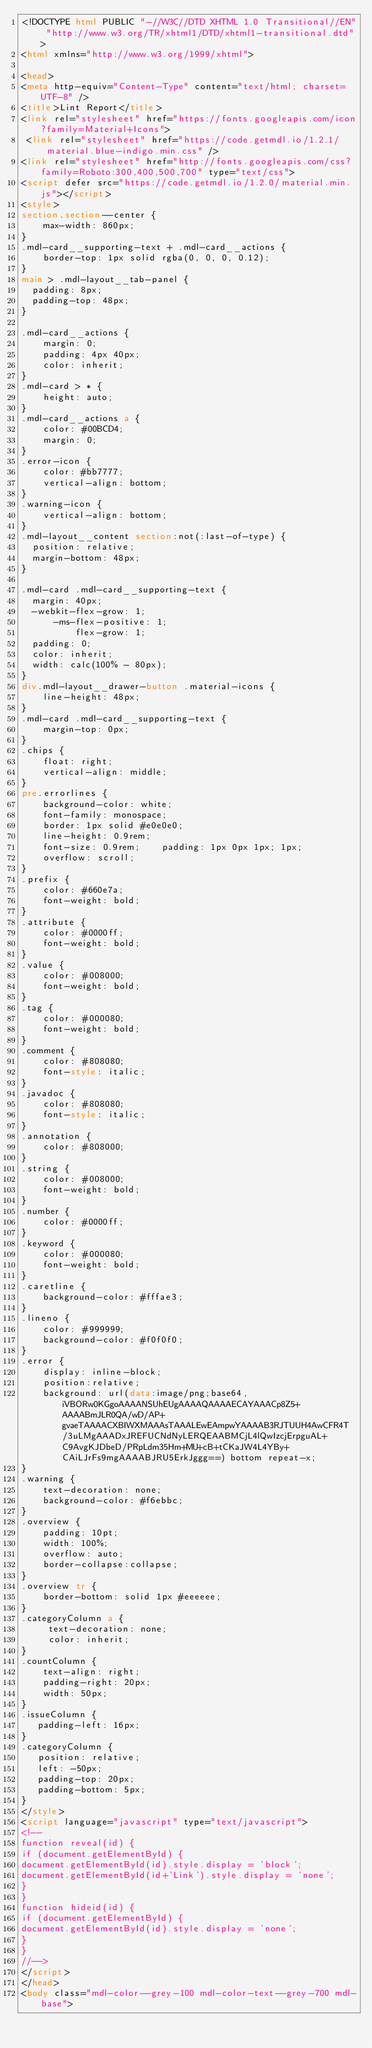Convert code to text. <code><loc_0><loc_0><loc_500><loc_500><_HTML_><!DOCTYPE html PUBLIC "-//W3C//DTD XHTML 1.0 Transitional//EN" "http://www.w3.org/TR/xhtml1/DTD/xhtml1-transitional.dtd">
<html xmlns="http://www.w3.org/1999/xhtml">

<head>
<meta http-equiv="Content-Type" content="text/html; charset=UTF-8" />
<title>Lint Report</title>
<link rel="stylesheet" href="https://fonts.googleapis.com/icon?family=Material+Icons">
 <link rel="stylesheet" href="https://code.getmdl.io/1.2.1/material.blue-indigo.min.css" />
<link rel="stylesheet" href="http://fonts.googleapis.com/css?family=Roboto:300,400,500,700" type="text/css">
<script defer src="https://code.getmdl.io/1.2.0/material.min.js"></script>
<style>
section.section--center {
    max-width: 860px;
}
.mdl-card__supporting-text + .mdl-card__actions {
    border-top: 1px solid rgba(0, 0, 0, 0.12);
}
main > .mdl-layout__tab-panel {
  padding: 8px;
  padding-top: 48px;
}

.mdl-card__actions {
    margin: 0;
    padding: 4px 40px;
    color: inherit;
}
.mdl-card > * {
    height: auto;
}
.mdl-card__actions a {
    color: #00BCD4;
    margin: 0;
}
.error-icon {
    color: #bb7777;
    vertical-align: bottom;
}
.warning-icon {
    vertical-align: bottom;
}
.mdl-layout__content section:not(:last-of-type) {
  position: relative;
  margin-bottom: 48px;
}

.mdl-card .mdl-card__supporting-text {
  margin: 40px;
  -webkit-flex-grow: 1;
      -ms-flex-positive: 1;
          flex-grow: 1;
  padding: 0;
  color: inherit;
  width: calc(100% - 80px);
}
div.mdl-layout__drawer-button .material-icons {
    line-height: 48px;
}
.mdl-card .mdl-card__supporting-text {
    margin-top: 0px;
}
.chips {
    float: right;
    vertical-align: middle;
}
pre.errorlines {
    background-color: white;
    font-family: monospace;
    border: 1px solid #e0e0e0;
    line-height: 0.9rem;
    font-size: 0.9rem;    padding: 1px 0px 1px; 1px;
    overflow: scroll;
}
.prefix {
    color: #660e7a;
    font-weight: bold;
}
.attribute {
    color: #0000ff;
    font-weight: bold;
}
.value {
    color: #008000;
    font-weight: bold;
}
.tag {
    color: #000080;
    font-weight: bold;
}
.comment {
    color: #808080;
    font-style: italic;
}
.javadoc {
    color: #808080;
    font-style: italic;
}
.annotation {
    color: #808000;
}
.string {
    color: #008000;
    font-weight: bold;
}
.number {
    color: #0000ff;
}
.keyword {
    color: #000080;
    font-weight: bold;
}
.caretline {
    background-color: #fffae3;
}
.lineno {
    color: #999999;
    background-color: #f0f0f0;
}
.error {
    display: inline-block;
    position:relative;
    background: url(data:image/png;base64,iVBORw0KGgoAAAANSUhEUgAAAAQAAAAECAYAAACp8Z5+AAAABmJLR0QA/wD/AP+gvaeTAAAACXBIWXMAAAsTAAALEwEAmpwYAAAAB3RJTUUH4AwCFR4T/3uLMgAAADxJREFUCNdNyLERQEAABMCjL4lQwIzcjErpguAL+C9AvgKJDbeD/PRpLdm35Hm+MU+cB+tCKaJW4L4YBy+CAiLJrFs9mgAAAABJRU5ErkJggg==) bottom repeat-x;
}
.warning {
    text-decoration: none;
    background-color: #f6ebbc;
}
.overview {
    padding: 10pt;
    width: 100%;
    overflow: auto;
    border-collapse:collapse;
}
.overview tr {
    border-bottom: solid 1px #eeeeee;
}
.categoryColumn a {
     text-decoration: none;
     color: inherit;
}
.countColumn {
    text-align: right;
    padding-right: 20px;
    width: 50px;
}
.issueColumn {
   padding-left: 16px;
}
.categoryColumn {
   position: relative;
   left: -50px;
   padding-top: 20px;
   padding-bottom: 5px;
}
</style>
<script language="javascript" type="text/javascript"> 
<!--
function reveal(id) {
if (document.getElementById) {
document.getElementById(id).style.display = 'block';
document.getElementById(id+'Link').style.display = 'none';
}
}
function hideid(id) {
if (document.getElementById) {
document.getElementById(id).style.display = 'none';
}
}
//--> 
</script>
</head>
<body class="mdl-color--grey-100 mdl-color-text--grey-700 mdl-base"></code> 